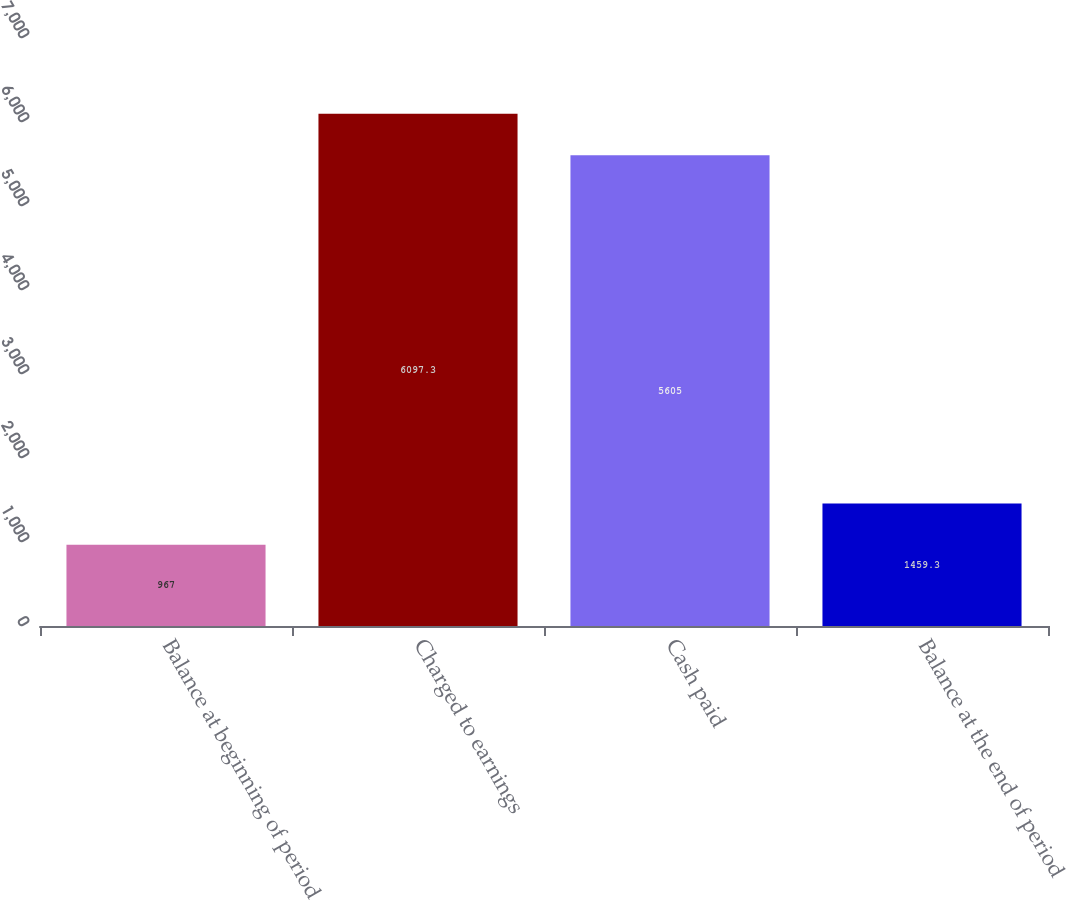<chart> <loc_0><loc_0><loc_500><loc_500><bar_chart><fcel>Balance at beginning of period<fcel>Charged to earnings<fcel>Cash paid<fcel>Balance at the end of period<nl><fcel>967<fcel>6097.3<fcel>5605<fcel>1459.3<nl></chart> 